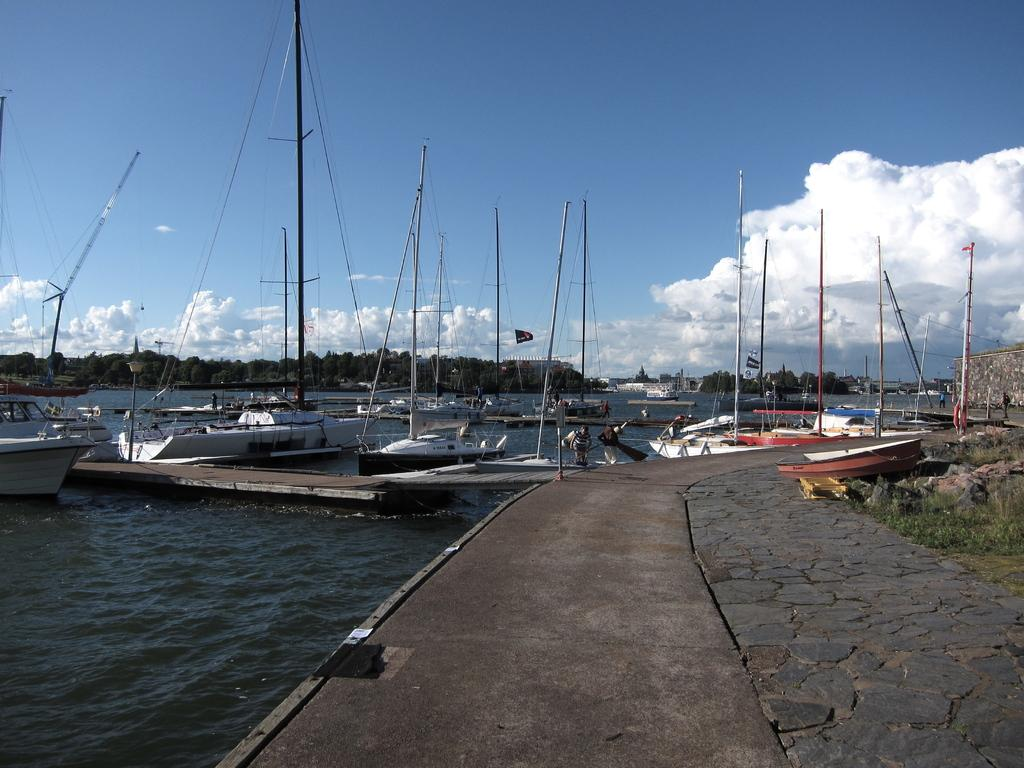What is the main subject of the picture? The main subject of the picture is a way. What can be seen near the way in the image? There are boats on the water beside the way. What is visible in the background of the image? There are trees and other objects in the background of the image. How would you describe the sky in the image? The sky is cloudy in the image. How much value does the quicksand have in the image? There is no quicksand present in the image, so it does not have any value. What type of journey is depicted in the image? The image does not depict a journey; it shows a way, boats, trees, and a cloudy sky. 